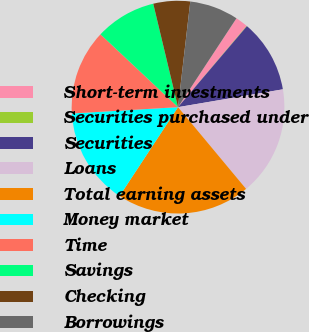<chart> <loc_0><loc_0><loc_500><loc_500><pie_chart><fcel>Short-term investments<fcel>Securities purchased under<fcel>Securities<fcel>Loans<fcel>Total earning assets<fcel>Money market<fcel>Time<fcel>Savings<fcel>Checking<fcel>Borrowings<nl><fcel>1.9%<fcel>0.06%<fcel>11.1%<fcel>16.63%<fcel>20.31%<fcel>14.79%<fcel>12.95%<fcel>9.26%<fcel>5.58%<fcel>7.42%<nl></chart> 